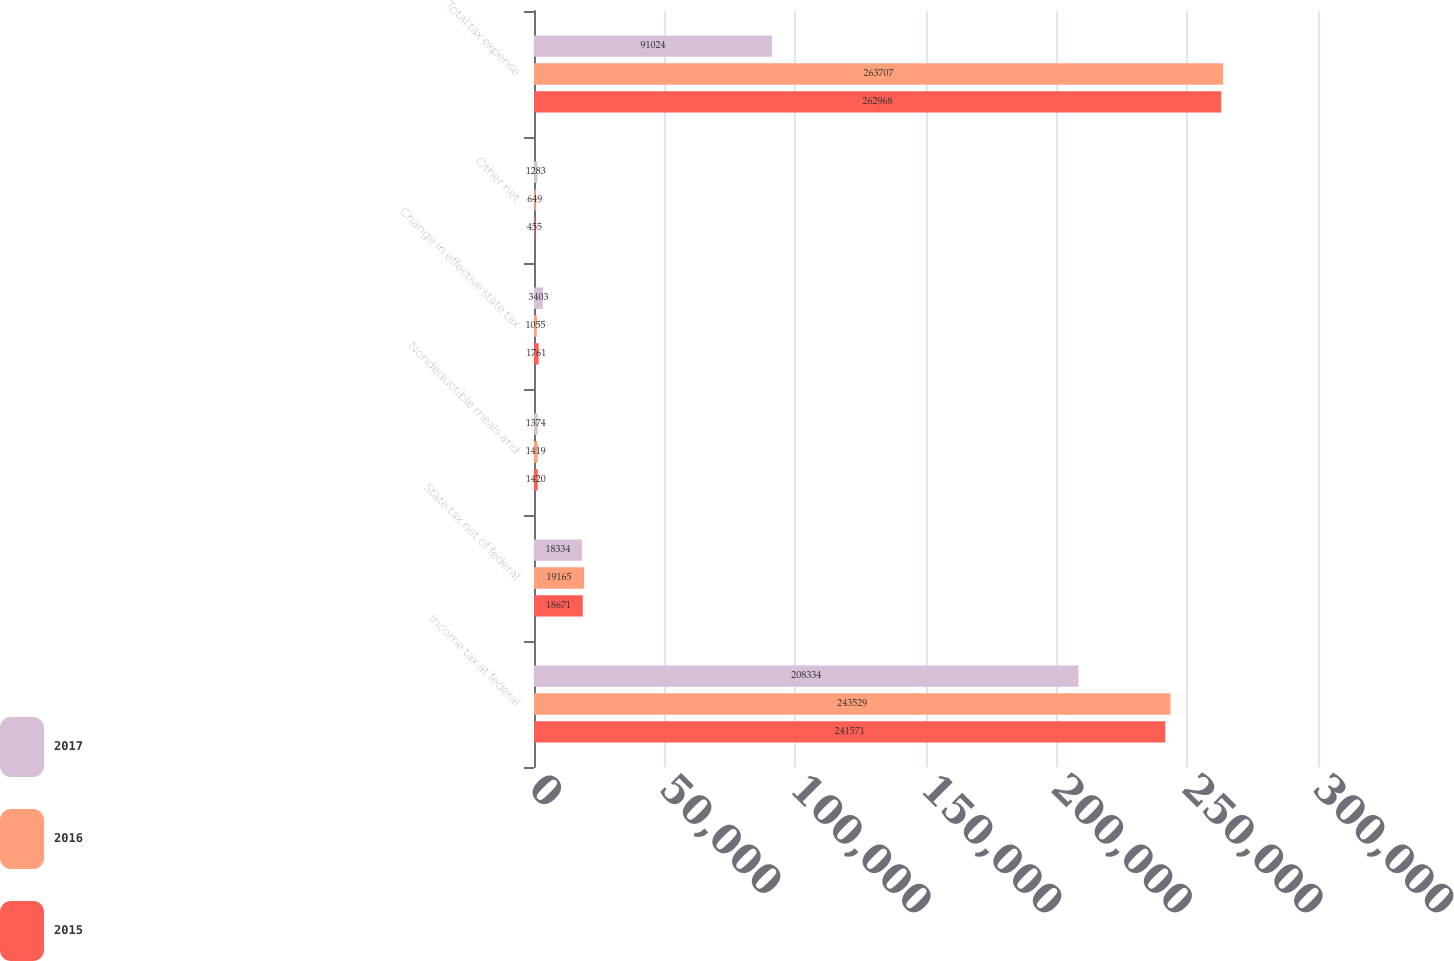Convert chart. <chart><loc_0><loc_0><loc_500><loc_500><stacked_bar_chart><ecel><fcel>Income tax at federal<fcel>State tax net of federal<fcel>Nondeductible meals and<fcel>Change in effective state tax<fcel>Other net<fcel>Total tax expense<nl><fcel>2017<fcel>208334<fcel>18334<fcel>1374<fcel>3403<fcel>1283<fcel>91024<nl><fcel>2016<fcel>243529<fcel>19165<fcel>1419<fcel>1055<fcel>649<fcel>263707<nl><fcel>2015<fcel>241571<fcel>18671<fcel>1420<fcel>1761<fcel>455<fcel>262968<nl></chart> 